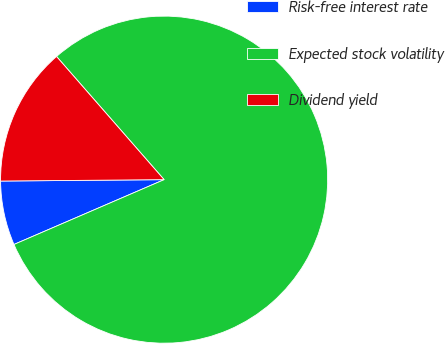<chart> <loc_0><loc_0><loc_500><loc_500><pie_chart><fcel>Risk-free interest rate<fcel>Expected stock volatility<fcel>Dividend yield<nl><fcel>6.35%<fcel>79.94%<fcel>13.71%<nl></chart> 